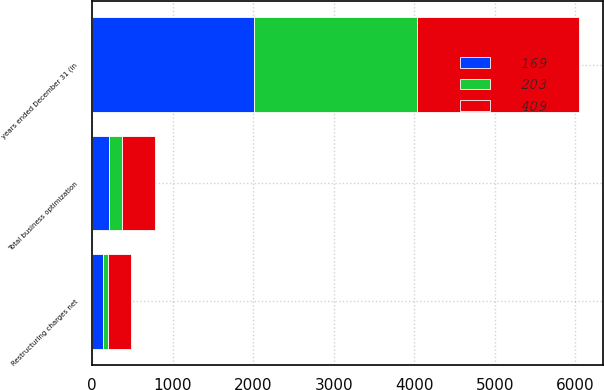Convert chart. <chart><loc_0><loc_0><loc_500><loc_500><stacked_bar_chart><ecel><fcel>years ended December 31 (in<fcel>Restructuring charges net<fcel>Total business optimization<nl><fcel>203<fcel>2017<fcel>70<fcel>169<nl><fcel>409<fcel>2016<fcel>285<fcel>409<nl><fcel>169<fcel>2015<fcel>130<fcel>203<nl></chart> 